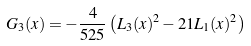Convert formula to latex. <formula><loc_0><loc_0><loc_500><loc_500>G _ { 3 } ( x ) = - \frac { 4 } { 5 2 5 } \left ( L _ { 3 } ( x ) ^ { 2 } - 2 1 L _ { 1 } ( x ) ^ { 2 } \right )</formula> 